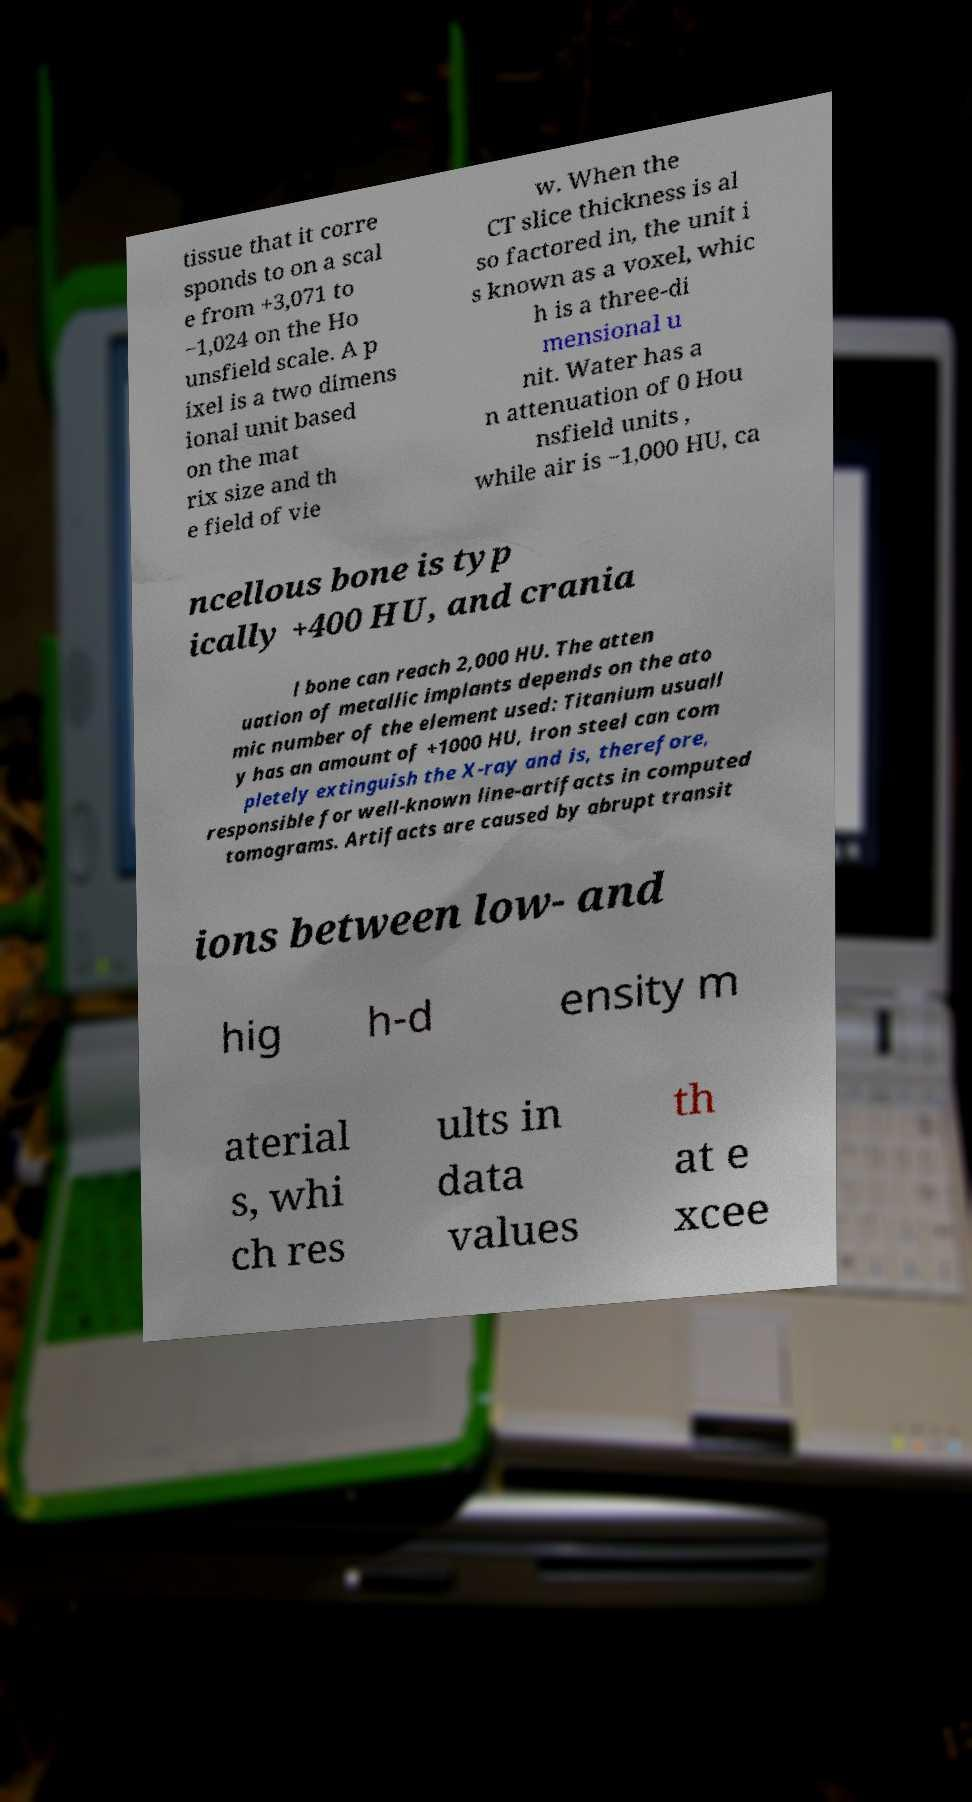For documentation purposes, I need the text within this image transcribed. Could you provide that? tissue that it corre sponds to on a scal e from +3,071 to −1,024 on the Ho unsfield scale. A p ixel is a two dimens ional unit based on the mat rix size and th e field of vie w. When the CT slice thickness is al so factored in, the unit i s known as a voxel, whic h is a three-di mensional u nit. Water has a n attenuation of 0 Hou nsfield units , while air is −1,000 HU, ca ncellous bone is typ ically +400 HU, and crania l bone can reach 2,000 HU. The atten uation of metallic implants depends on the ato mic number of the element used: Titanium usuall y has an amount of +1000 HU, iron steel can com pletely extinguish the X-ray and is, therefore, responsible for well-known line-artifacts in computed tomograms. Artifacts are caused by abrupt transit ions between low- and hig h-d ensity m aterial s, whi ch res ults in data values th at e xcee 